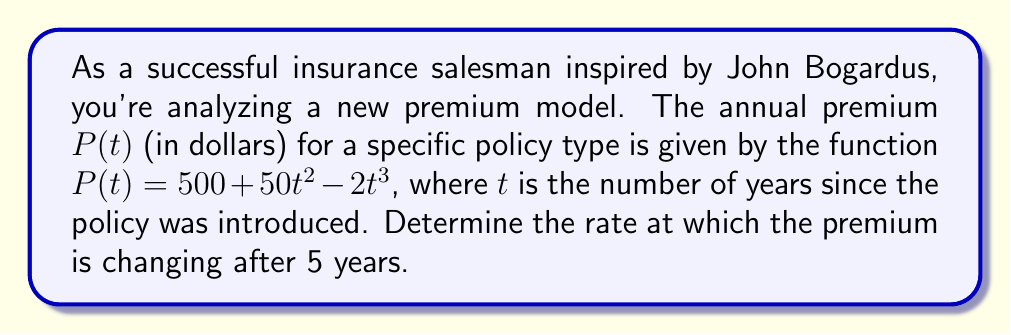Teach me how to tackle this problem. To solve this problem, we need to use differential calculus to find the rate of change of the premium function at $t = 5$ years. Here's the step-by-step process:

1) The rate of change of the premium is given by the derivative of $P(t)$ with respect to $t$. Let's call this $P'(t)$.

2) To find $P'(t)$, we differentiate each term of $P(t)$:

   $P(t) = 500 + 50t^2 - 2t^3$

   $P'(t) = 0 + 50(2t) - 2(3t^2)$

   $P'(t) = 100t - 6t^2$

3) Now that we have the derivative, we can find the rate of change at $t = 5$ by evaluating $P'(5)$:

   $P'(5) = 100(5) - 6(5^2)$
   
   $P'(5) = 500 - 6(25)$
   
   $P'(5) = 500 - 150 = 350$

4) The units of $P'(t)$ are dollars per year, as we're measuring the change in premium (dollars) with respect to time (years).
Answer: The premium is changing at a rate of $350 per year after 5 years. 